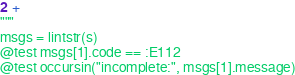Convert code to text. <code><loc_0><loc_0><loc_500><loc_500><_Julia_>2 +
"""
msgs = lintstr(s)
@test msgs[1].code == :E112
@test occursin("incomplete:", msgs[1].message)
</code> 